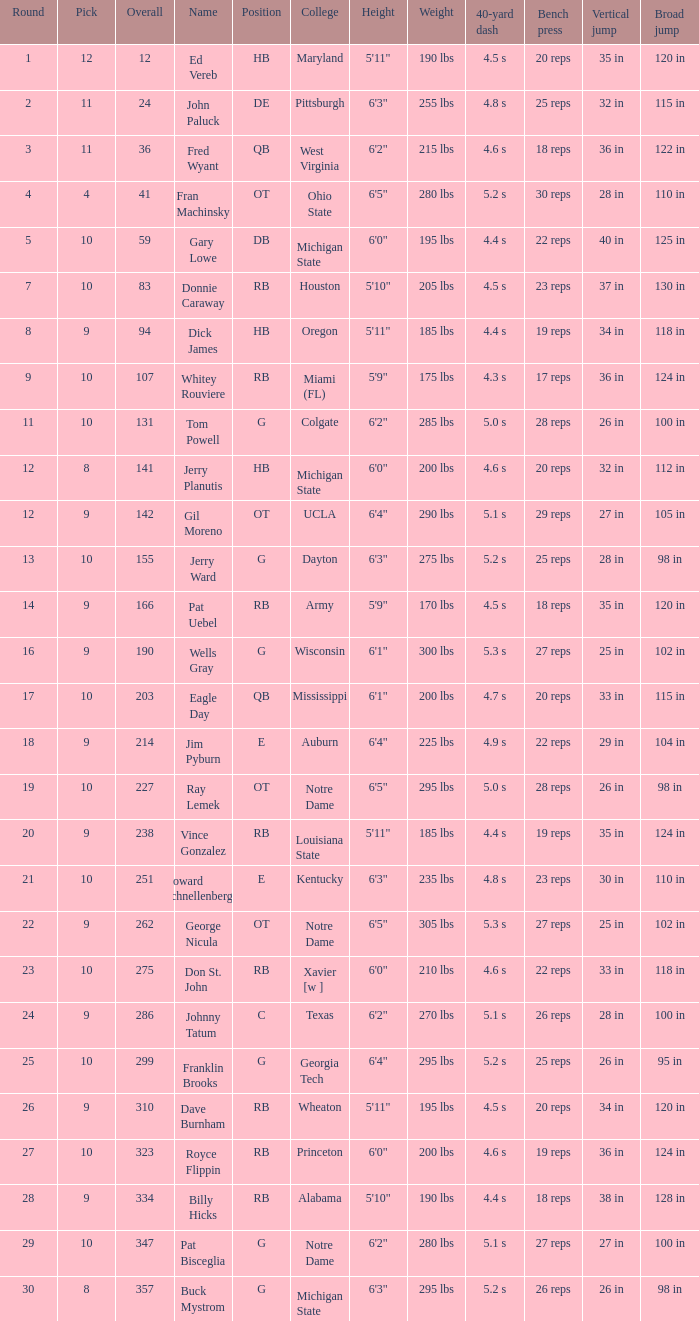What is the average number of rounds for billy hicks who had an overall pick number bigger than 310? 28.0. 